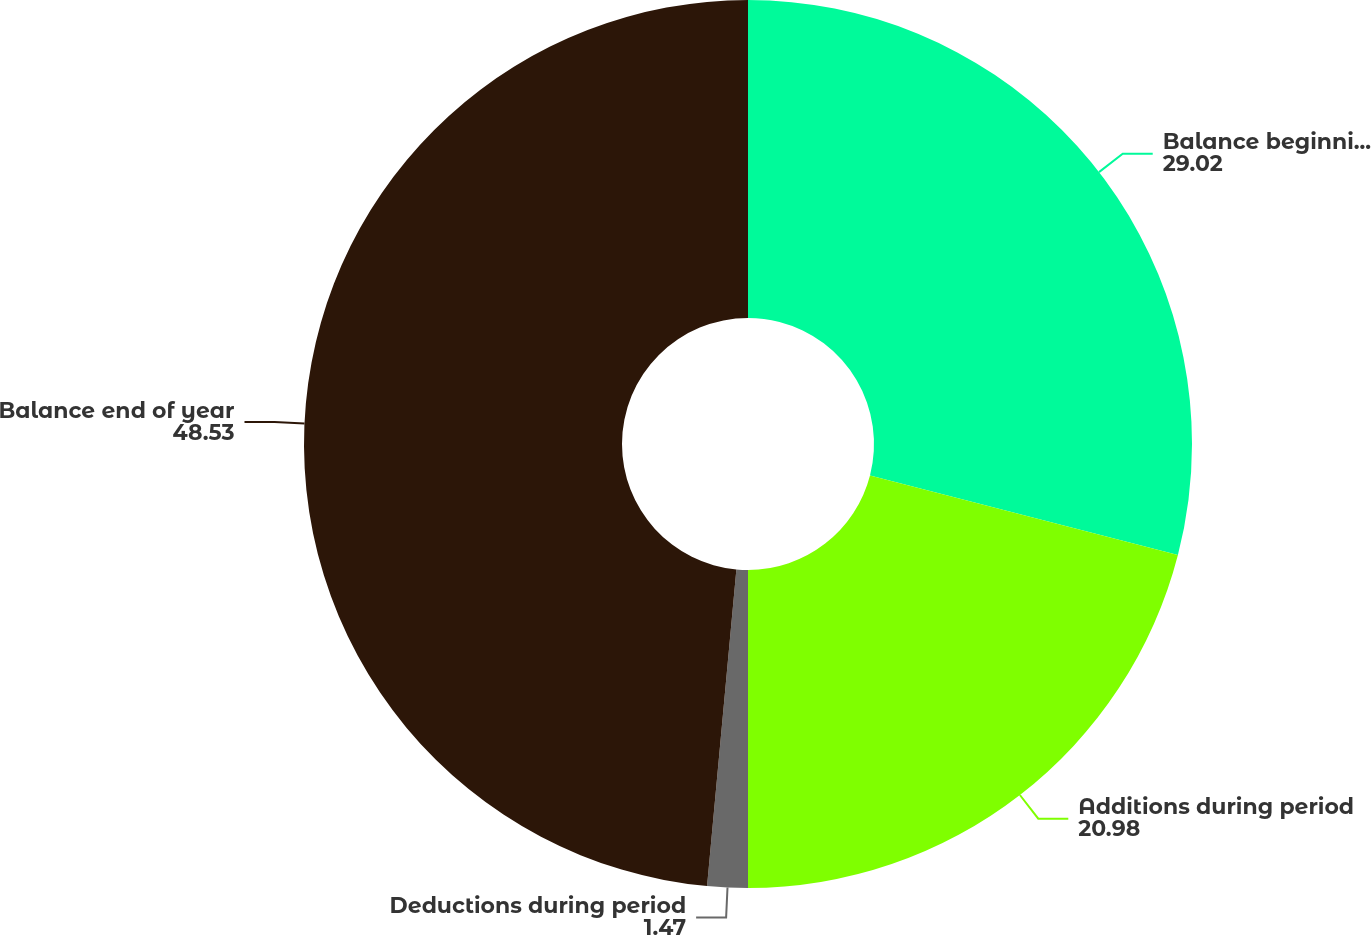<chart> <loc_0><loc_0><loc_500><loc_500><pie_chart><fcel>Balance beginning of year<fcel>Additions during period<fcel>Deductions during period<fcel>Balance end of year<nl><fcel>29.02%<fcel>20.98%<fcel>1.47%<fcel>48.53%<nl></chart> 